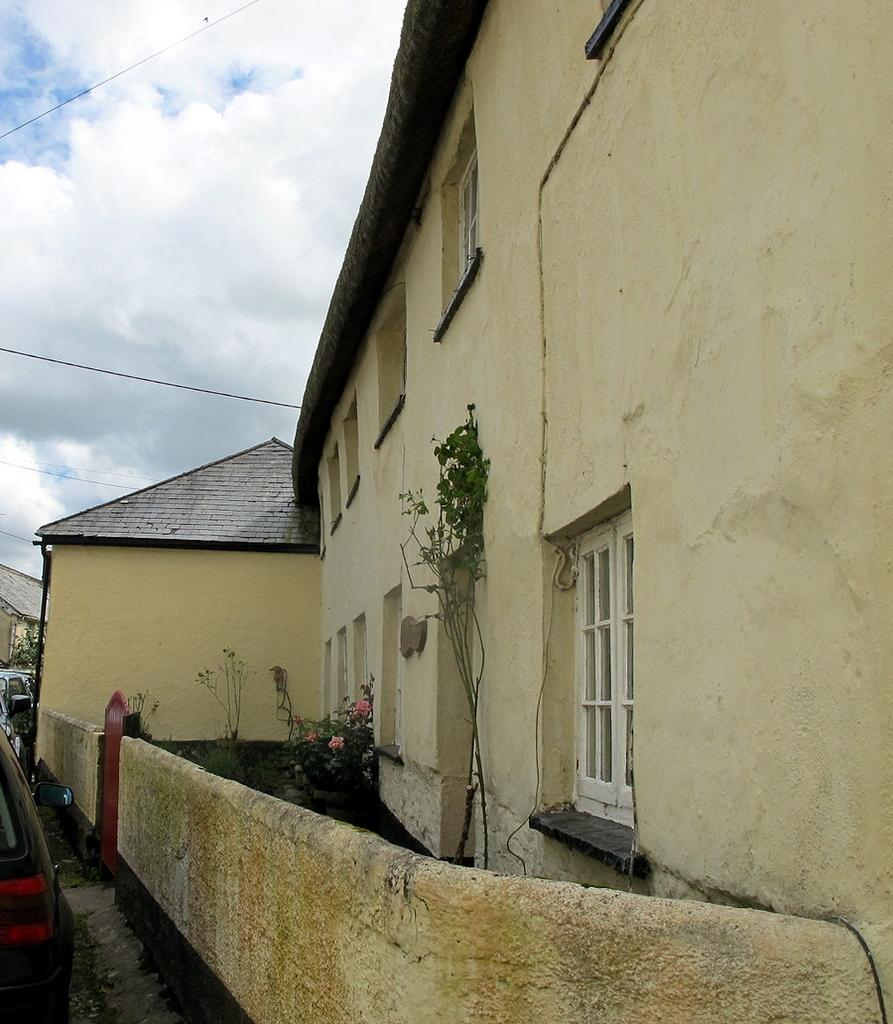What type of structures can be seen in the image? There are buildings in the image. What feature is attached to one of the buildings? A gate is attached to one of the buildings. What type of vegetation is present in the image? There are plants with flowers in the image. What type of vehicles are in front of the building? Cars are present in front of the building. What type of utility infrastructure is visible in the image? Wires are visible in the image. What is visible in the background of the image? The sky is visible in the background of the image. Can you tell me where the kitten is playing with a store in the image? There is no kitten or store present in the image. What type of material is the building rubbing against in the image? There is no indication of any building rubbing against any material in the image. 